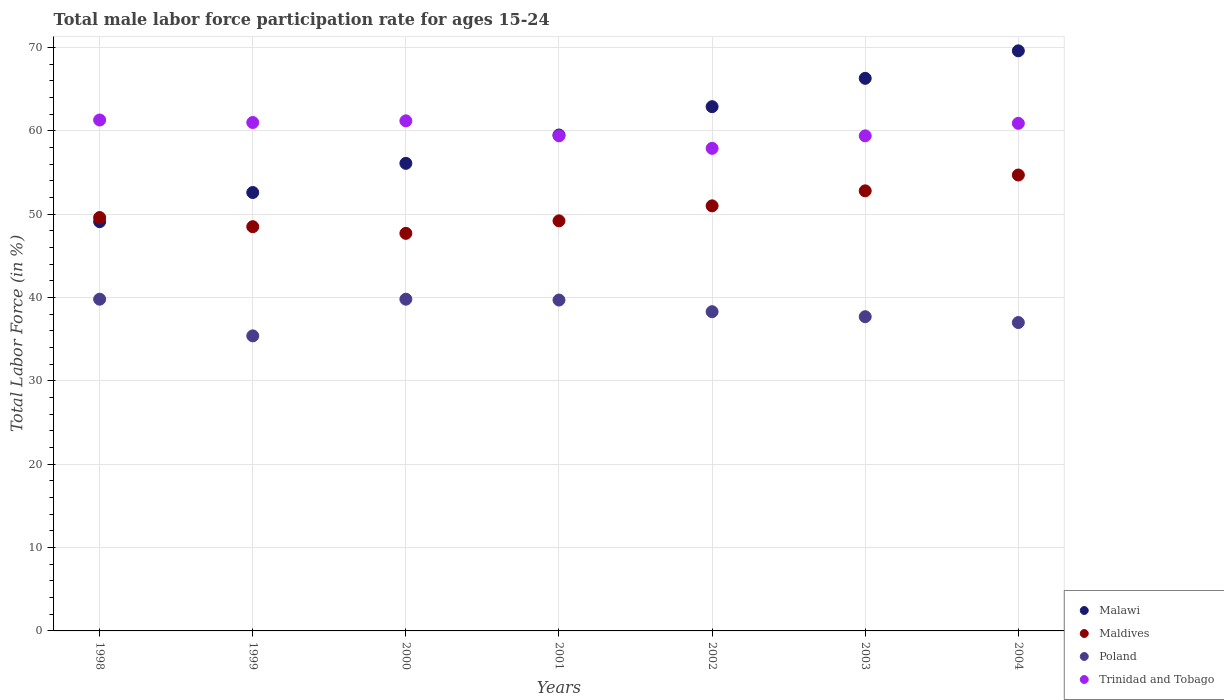What is the male labor force participation rate in Maldives in 1999?
Your answer should be compact. 48.5. Across all years, what is the maximum male labor force participation rate in Poland?
Provide a succinct answer. 39.8. Across all years, what is the minimum male labor force participation rate in Trinidad and Tobago?
Offer a very short reply. 57.9. In which year was the male labor force participation rate in Trinidad and Tobago maximum?
Offer a terse response. 1998. What is the total male labor force participation rate in Trinidad and Tobago in the graph?
Your answer should be compact. 421.1. What is the difference between the male labor force participation rate in Malawi in 2000 and that in 2001?
Offer a very short reply. -3.4. What is the difference between the male labor force participation rate in Trinidad and Tobago in 1998 and the male labor force participation rate in Malawi in 2003?
Provide a short and direct response. -5. What is the average male labor force participation rate in Poland per year?
Offer a very short reply. 38.24. In the year 2003, what is the difference between the male labor force participation rate in Poland and male labor force participation rate in Malawi?
Offer a terse response. -28.6. In how many years, is the male labor force participation rate in Malawi greater than 44 %?
Your answer should be compact. 7. What is the ratio of the male labor force participation rate in Trinidad and Tobago in 2000 to that in 2001?
Offer a terse response. 1.03. Is the difference between the male labor force participation rate in Poland in 2000 and 2004 greater than the difference between the male labor force participation rate in Malawi in 2000 and 2004?
Offer a very short reply. Yes. What is the difference between the highest and the second highest male labor force participation rate in Trinidad and Tobago?
Provide a succinct answer. 0.1. What is the difference between the highest and the lowest male labor force participation rate in Maldives?
Provide a succinct answer. 7. Is the sum of the male labor force participation rate in Trinidad and Tobago in 2001 and 2003 greater than the maximum male labor force participation rate in Maldives across all years?
Your response must be concise. Yes. Is it the case that in every year, the sum of the male labor force participation rate in Trinidad and Tobago and male labor force participation rate in Maldives  is greater than the sum of male labor force participation rate in Malawi and male labor force participation rate in Poland?
Give a very brief answer. No. Is the male labor force participation rate in Maldives strictly greater than the male labor force participation rate in Poland over the years?
Keep it short and to the point. Yes. How many years are there in the graph?
Ensure brevity in your answer.  7. Does the graph contain any zero values?
Offer a terse response. No. Does the graph contain grids?
Your answer should be very brief. Yes. Where does the legend appear in the graph?
Provide a succinct answer. Bottom right. How many legend labels are there?
Keep it short and to the point. 4. What is the title of the graph?
Give a very brief answer. Total male labor force participation rate for ages 15-24. Does "Poland" appear as one of the legend labels in the graph?
Your response must be concise. Yes. What is the Total Labor Force (in %) in Malawi in 1998?
Make the answer very short. 49.1. What is the Total Labor Force (in %) in Maldives in 1998?
Provide a short and direct response. 49.6. What is the Total Labor Force (in %) of Poland in 1998?
Provide a succinct answer. 39.8. What is the Total Labor Force (in %) of Trinidad and Tobago in 1998?
Your response must be concise. 61.3. What is the Total Labor Force (in %) of Malawi in 1999?
Ensure brevity in your answer.  52.6. What is the Total Labor Force (in %) of Maldives in 1999?
Keep it short and to the point. 48.5. What is the Total Labor Force (in %) of Poland in 1999?
Your answer should be compact. 35.4. What is the Total Labor Force (in %) in Malawi in 2000?
Provide a succinct answer. 56.1. What is the Total Labor Force (in %) of Maldives in 2000?
Make the answer very short. 47.7. What is the Total Labor Force (in %) of Poland in 2000?
Offer a terse response. 39.8. What is the Total Labor Force (in %) in Trinidad and Tobago in 2000?
Provide a short and direct response. 61.2. What is the Total Labor Force (in %) of Malawi in 2001?
Make the answer very short. 59.5. What is the Total Labor Force (in %) in Maldives in 2001?
Offer a very short reply. 49.2. What is the Total Labor Force (in %) of Poland in 2001?
Your answer should be compact. 39.7. What is the Total Labor Force (in %) of Trinidad and Tobago in 2001?
Provide a succinct answer. 59.4. What is the Total Labor Force (in %) in Malawi in 2002?
Your answer should be compact. 62.9. What is the Total Labor Force (in %) of Maldives in 2002?
Provide a succinct answer. 51. What is the Total Labor Force (in %) of Poland in 2002?
Offer a terse response. 38.3. What is the Total Labor Force (in %) of Trinidad and Tobago in 2002?
Keep it short and to the point. 57.9. What is the Total Labor Force (in %) of Malawi in 2003?
Your answer should be very brief. 66.3. What is the Total Labor Force (in %) of Maldives in 2003?
Make the answer very short. 52.8. What is the Total Labor Force (in %) of Poland in 2003?
Keep it short and to the point. 37.7. What is the Total Labor Force (in %) of Trinidad and Tobago in 2003?
Keep it short and to the point. 59.4. What is the Total Labor Force (in %) in Malawi in 2004?
Your answer should be very brief. 69.6. What is the Total Labor Force (in %) in Maldives in 2004?
Your response must be concise. 54.7. What is the Total Labor Force (in %) of Poland in 2004?
Provide a short and direct response. 37. What is the Total Labor Force (in %) of Trinidad and Tobago in 2004?
Provide a succinct answer. 60.9. Across all years, what is the maximum Total Labor Force (in %) of Malawi?
Provide a succinct answer. 69.6. Across all years, what is the maximum Total Labor Force (in %) of Maldives?
Make the answer very short. 54.7. Across all years, what is the maximum Total Labor Force (in %) of Poland?
Your response must be concise. 39.8. Across all years, what is the maximum Total Labor Force (in %) in Trinidad and Tobago?
Ensure brevity in your answer.  61.3. Across all years, what is the minimum Total Labor Force (in %) of Malawi?
Offer a terse response. 49.1. Across all years, what is the minimum Total Labor Force (in %) of Maldives?
Make the answer very short. 47.7. Across all years, what is the minimum Total Labor Force (in %) in Poland?
Provide a succinct answer. 35.4. Across all years, what is the minimum Total Labor Force (in %) in Trinidad and Tobago?
Provide a succinct answer. 57.9. What is the total Total Labor Force (in %) of Malawi in the graph?
Your answer should be compact. 416.1. What is the total Total Labor Force (in %) of Maldives in the graph?
Your answer should be very brief. 353.5. What is the total Total Labor Force (in %) of Poland in the graph?
Make the answer very short. 267.7. What is the total Total Labor Force (in %) of Trinidad and Tobago in the graph?
Give a very brief answer. 421.1. What is the difference between the Total Labor Force (in %) in Malawi in 1998 and that in 1999?
Keep it short and to the point. -3.5. What is the difference between the Total Labor Force (in %) of Poland in 1998 and that in 1999?
Offer a terse response. 4.4. What is the difference between the Total Labor Force (in %) of Poland in 1998 and that in 2000?
Provide a short and direct response. 0. What is the difference between the Total Labor Force (in %) of Trinidad and Tobago in 1998 and that in 2000?
Offer a terse response. 0.1. What is the difference between the Total Labor Force (in %) in Poland in 1998 and that in 2001?
Ensure brevity in your answer.  0.1. What is the difference between the Total Labor Force (in %) in Trinidad and Tobago in 1998 and that in 2001?
Keep it short and to the point. 1.9. What is the difference between the Total Labor Force (in %) of Malawi in 1998 and that in 2002?
Provide a short and direct response. -13.8. What is the difference between the Total Labor Force (in %) in Poland in 1998 and that in 2002?
Ensure brevity in your answer.  1.5. What is the difference between the Total Labor Force (in %) in Malawi in 1998 and that in 2003?
Your response must be concise. -17.2. What is the difference between the Total Labor Force (in %) in Malawi in 1998 and that in 2004?
Your answer should be compact. -20.5. What is the difference between the Total Labor Force (in %) of Maldives in 1998 and that in 2004?
Offer a terse response. -5.1. What is the difference between the Total Labor Force (in %) of Malawi in 1999 and that in 2000?
Your answer should be compact. -3.5. What is the difference between the Total Labor Force (in %) of Maldives in 1999 and that in 2000?
Your answer should be compact. 0.8. What is the difference between the Total Labor Force (in %) in Trinidad and Tobago in 1999 and that in 2000?
Your response must be concise. -0.2. What is the difference between the Total Labor Force (in %) of Maldives in 1999 and that in 2001?
Provide a short and direct response. -0.7. What is the difference between the Total Labor Force (in %) in Poland in 1999 and that in 2001?
Provide a short and direct response. -4.3. What is the difference between the Total Labor Force (in %) in Trinidad and Tobago in 1999 and that in 2001?
Offer a terse response. 1.6. What is the difference between the Total Labor Force (in %) in Malawi in 1999 and that in 2002?
Offer a terse response. -10.3. What is the difference between the Total Labor Force (in %) in Trinidad and Tobago in 1999 and that in 2002?
Your answer should be compact. 3.1. What is the difference between the Total Labor Force (in %) of Malawi in 1999 and that in 2003?
Your answer should be compact. -13.7. What is the difference between the Total Labor Force (in %) of Poland in 1999 and that in 2003?
Make the answer very short. -2.3. What is the difference between the Total Labor Force (in %) in Trinidad and Tobago in 1999 and that in 2003?
Provide a short and direct response. 1.6. What is the difference between the Total Labor Force (in %) in Maldives in 1999 and that in 2004?
Your answer should be compact. -6.2. What is the difference between the Total Labor Force (in %) of Poland in 1999 and that in 2004?
Make the answer very short. -1.6. What is the difference between the Total Labor Force (in %) of Poland in 2000 and that in 2001?
Make the answer very short. 0.1. What is the difference between the Total Labor Force (in %) in Trinidad and Tobago in 2000 and that in 2001?
Provide a succinct answer. 1.8. What is the difference between the Total Labor Force (in %) of Malawi in 2000 and that in 2002?
Your answer should be compact. -6.8. What is the difference between the Total Labor Force (in %) of Malawi in 2000 and that in 2003?
Give a very brief answer. -10.2. What is the difference between the Total Labor Force (in %) in Maldives in 2000 and that in 2004?
Keep it short and to the point. -7. What is the difference between the Total Labor Force (in %) in Poland in 2000 and that in 2004?
Offer a terse response. 2.8. What is the difference between the Total Labor Force (in %) of Malawi in 2001 and that in 2002?
Ensure brevity in your answer.  -3.4. What is the difference between the Total Labor Force (in %) of Poland in 2001 and that in 2002?
Keep it short and to the point. 1.4. What is the difference between the Total Labor Force (in %) in Malawi in 2001 and that in 2003?
Your answer should be very brief. -6.8. What is the difference between the Total Labor Force (in %) of Maldives in 2001 and that in 2003?
Provide a short and direct response. -3.6. What is the difference between the Total Labor Force (in %) of Poland in 2001 and that in 2003?
Keep it short and to the point. 2. What is the difference between the Total Labor Force (in %) in Malawi in 2002 and that in 2003?
Your answer should be very brief. -3.4. What is the difference between the Total Labor Force (in %) in Maldives in 2002 and that in 2003?
Keep it short and to the point. -1.8. What is the difference between the Total Labor Force (in %) of Maldives in 2002 and that in 2004?
Your answer should be very brief. -3.7. What is the difference between the Total Labor Force (in %) of Poland in 2003 and that in 2004?
Keep it short and to the point. 0.7. What is the difference between the Total Labor Force (in %) in Malawi in 1998 and the Total Labor Force (in %) in Poland in 1999?
Make the answer very short. 13.7. What is the difference between the Total Labor Force (in %) in Maldives in 1998 and the Total Labor Force (in %) in Poland in 1999?
Your response must be concise. 14.2. What is the difference between the Total Labor Force (in %) of Poland in 1998 and the Total Labor Force (in %) of Trinidad and Tobago in 1999?
Make the answer very short. -21.2. What is the difference between the Total Labor Force (in %) of Malawi in 1998 and the Total Labor Force (in %) of Maldives in 2000?
Ensure brevity in your answer.  1.4. What is the difference between the Total Labor Force (in %) in Maldives in 1998 and the Total Labor Force (in %) in Trinidad and Tobago in 2000?
Keep it short and to the point. -11.6. What is the difference between the Total Labor Force (in %) of Poland in 1998 and the Total Labor Force (in %) of Trinidad and Tobago in 2000?
Provide a short and direct response. -21.4. What is the difference between the Total Labor Force (in %) of Malawi in 1998 and the Total Labor Force (in %) of Poland in 2001?
Keep it short and to the point. 9.4. What is the difference between the Total Labor Force (in %) of Malawi in 1998 and the Total Labor Force (in %) of Trinidad and Tobago in 2001?
Provide a short and direct response. -10.3. What is the difference between the Total Labor Force (in %) of Maldives in 1998 and the Total Labor Force (in %) of Poland in 2001?
Your answer should be very brief. 9.9. What is the difference between the Total Labor Force (in %) of Poland in 1998 and the Total Labor Force (in %) of Trinidad and Tobago in 2001?
Provide a succinct answer. -19.6. What is the difference between the Total Labor Force (in %) in Malawi in 1998 and the Total Labor Force (in %) in Maldives in 2002?
Make the answer very short. -1.9. What is the difference between the Total Labor Force (in %) of Malawi in 1998 and the Total Labor Force (in %) of Trinidad and Tobago in 2002?
Give a very brief answer. -8.8. What is the difference between the Total Labor Force (in %) of Poland in 1998 and the Total Labor Force (in %) of Trinidad and Tobago in 2002?
Provide a short and direct response. -18.1. What is the difference between the Total Labor Force (in %) of Malawi in 1998 and the Total Labor Force (in %) of Maldives in 2003?
Provide a short and direct response. -3.7. What is the difference between the Total Labor Force (in %) of Malawi in 1998 and the Total Labor Force (in %) of Poland in 2003?
Your response must be concise. 11.4. What is the difference between the Total Labor Force (in %) of Maldives in 1998 and the Total Labor Force (in %) of Trinidad and Tobago in 2003?
Offer a terse response. -9.8. What is the difference between the Total Labor Force (in %) in Poland in 1998 and the Total Labor Force (in %) in Trinidad and Tobago in 2003?
Make the answer very short. -19.6. What is the difference between the Total Labor Force (in %) in Malawi in 1998 and the Total Labor Force (in %) in Maldives in 2004?
Keep it short and to the point. -5.6. What is the difference between the Total Labor Force (in %) of Maldives in 1998 and the Total Labor Force (in %) of Trinidad and Tobago in 2004?
Ensure brevity in your answer.  -11.3. What is the difference between the Total Labor Force (in %) of Poland in 1998 and the Total Labor Force (in %) of Trinidad and Tobago in 2004?
Provide a succinct answer. -21.1. What is the difference between the Total Labor Force (in %) of Malawi in 1999 and the Total Labor Force (in %) of Poland in 2000?
Your response must be concise. 12.8. What is the difference between the Total Labor Force (in %) of Maldives in 1999 and the Total Labor Force (in %) of Trinidad and Tobago in 2000?
Provide a short and direct response. -12.7. What is the difference between the Total Labor Force (in %) in Poland in 1999 and the Total Labor Force (in %) in Trinidad and Tobago in 2000?
Offer a terse response. -25.8. What is the difference between the Total Labor Force (in %) of Malawi in 1999 and the Total Labor Force (in %) of Maldives in 2001?
Make the answer very short. 3.4. What is the difference between the Total Labor Force (in %) in Malawi in 1999 and the Total Labor Force (in %) in Trinidad and Tobago in 2001?
Make the answer very short. -6.8. What is the difference between the Total Labor Force (in %) in Maldives in 1999 and the Total Labor Force (in %) in Trinidad and Tobago in 2001?
Ensure brevity in your answer.  -10.9. What is the difference between the Total Labor Force (in %) of Poland in 1999 and the Total Labor Force (in %) of Trinidad and Tobago in 2001?
Offer a very short reply. -24. What is the difference between the Total Labor Force (in %) in Malawi in 1999 and the Total Labor Force (in %) in Trinidad and Tobago in 2002?
Ensure brevity in your answer.  -5.3. What is the difference between the Total Labor Force (in %) in Poland in 1999 and the Total Labor Force (in %) in Trinidad and Tobago in 2002?
Your answer should be very brief. -22.5. What is the difference between the Total Labor Force (in %) in Malawi in 1999 and the Total Labor Force (in %) in Poland in 2003?
Offer a very short reply. 14.9. What is the difference between the Total Labor Force (in %) in Malawi in 1999 and the Total Labor Force (in %) in Trinidad and Tobago in 2003?
Make the answer very short. -6.8. What is the difference between the Total Labor Force (in %) in Maldives in 1999 and the Total Labor Force (in %) in Poland in 2003?
Provide a succinct answer. 10.8. What is the difference between the Total Labor Force (in %) in Maldives in 1999 and the Total Labor Force (in %) in Trinidad and Tobago in 2003?
Your response must be concise. -10.9. What is the difference between the Total Labor Force (in %) in Malawi in 1999 and the Total Labor Force (in %) in Maldives in 2004?
Provide a short and direct response. -2.1. What is the difference between the Total Labor Force (in %) in Malawi in 1999 and the Total Labor Force (in %) in Poland in 2004?
Your answer should be compact. 15.6. What is the difference between the Total Labor Force (in %) of Malawi in 1999 and the Total Labor Force (in %) of Trinidad and Tobago in 2004?
Give a very brief answer. -8.3. What is the difference between the Total Labor Force (in %) of Maldives in 1999 and the Total Labor Force (in %) of Trinidad and Tobago in 2004?
Offer a very short reply. -12.4. What is the difference between the Total Labor Force (in %) of Poland in 1999 and the Total Labor Force (in %) of Trinidad and Tobago in 2004?
Make the answer very short. -25.5. What is the difference between the Total Labor Force (in %) of Malawi in 2000 and the Total Labor Force (in %) of Poland in 2001?
Ensure brevity in your answer.  16.4. What is the difference between the Total Labor Force (in %) of Malawi in 2000 and the Total Labor Force (in %) of Trinidad and Tobago in 2001?
Provide a short and direct response. -3.3. What is the difference between the Total Labor Force (in %) in Maldives in 2000 and the Total Labor Force (in %) in Poland in 2001?
Offer a very short reply. 8. What is the difference between the Total Labor Force (in %) in Poland in 2000 and the Total Labor Force (in %) in Trinidad and Tobago in 2001?
Offer a very short reply. -19.6. What is the difference between the Total Labor Force (in %) of Malawi in 2000 and the Total Labor Force (in %) of Maldives in 2002?
Give a very brief answer. 5.1. What is the difference between the Total Labor Force (in %) of Malawi in 2000 and the Total Labor Force (in %) of Poland in 2002?
Your answer should be compact. 17.8. What is the difference between the Total Labor Force (in %) of Maldives in 2000 and the Total Labor Force (in %) of Poland in 2002?
Offer a very short reply. 9.4. What is the difference between the Total Labor Force (in %) in Poland in 2000 and the Total Labor Force (in %) in Trinidad and Tobago in 2002?
Your answer should be compact. -18.1. What is the difference between the Total Labor Force (in %) of Malawi in 2000 and the Total Labor Force (in %) of Maldives in 2003?
Provide a succinct answer. 3.3. What is the difference between the Total Labor Force (in %) in Poland in 2000 and the Total Labor Force (in %) in Trinidad and Tobago in 2003?
Your answer should be very brief. -19.6. What is the difference between the Total Labor Force (in %) in Maldives in 2000 and the Total Labor Force (in %) in Poland in 2004?
Offer a terse response. 10.7. What is the difference between the Total Labor Force (in %) in Poland in 2000 and the Total Labor Force (in %) in Trinidad and Tobago in 2004?
Give a very brief answer. -21.1. What is the difference between the Total Labor Force (in %) in Malawi in 2001 and the Total Labor Force (in %) in Poland in 2002?
Your answer should be very brief. 21.2. What is the difference between the Total Labor Force (in %) of Malawi in 2001 and the Total Labor Force (in %) of Trinidad and Tobago in 2002?
Your answer should be very brief. 1.6. What is the difference between the Total Labor Force (in %) in Poland in 2001 and the Total Labor Force (in %) in Trinidad and Tobago in 2002?
Provide a succinct answer. -18.2. What is the difference between the Total Labor Force (in %) in Malawi in 2001 and the Total Labor Force (in %) in Maldives in 2003?
Provide a short and direct response. 6.7. What is the difference between the Total Labor Force (in %) of Malawi in 2001 and the Total Labor Force (in %) of Poland in 2003?
Keep it short and to the point. 21.8. What is the difference between the Total Labor Force (in %) in Poland in 2001 and the Total Labor Force (in %) in Trinidad and Tobago in 2003?
Offer a very short reply. -19.7. What is the difference between the Total Labor Force (in %) in Malawi in 2001 and the Total Labor Force (in %) in Poland in 2004?
Your answer should be compact. 22.5. What is the difference between the Total Labor Force (in %) in Maldives in 2001 and the Total Labor Force (in %) in Trinidad and Tobago in 2004?
Give a very brief answer. -11.7. What is the difference between the Total Labor Force (in %) in Poland in 2001 and the Total Labor Force (in %) in Trinidad and Tobago in 2004?
Your response must be concise. -21.2. What is the difference between the Total Labor Force (in %) in Malawi in 2002 and the Total Labor Force (in %) in Maldives in 2003?
Offer a terse response. 10.1. What is the difference between the Total Labor Force (in %) in Malawi in 2002 and the Total Labor Force (in %) in Poland in 2003?
Offer a terse response. 25.2. What is the difference between the Total Labor Force (in %) of Malawi in 2002 and the Total Labor Force (in %) of Trinidad and Tobago in 2003?
Give a very brief answer. 3.5. What is the difference between the Total Labor Force (in %) in Maldives in 2002 and the Total Labor Force (in %) in Poland in 2003?
Make the answer very short. 13.3. What is the difference between the Total Labor Force (in %) in Poland in 2002 and the Total Labor Force (in %) in Trinidad and Tobago in 2003?
Give a very brief answer. -21.1. What is the difference between the Total Labor Force (in %) of Malawi in 2002 and the Total Labor Force (in %) of Maldives in 2004?
Provide a short and direct response. 8.2. What is the difference between the Total Labor Force (in %) of Malawi in 2002 and the Total Labor Force (in %) of Poland in 2004?
Offer a terse response. 25.9. What is the difference between the Total Labor Force (in %) of Malawi in 2002 and the Total Labor Force (in %) of Trinidad and Tobago in 2004?
Your response must be concise. 2. What is the difference between the Total Labor Force (in %) of Maldives in 2002 and the Total Labor Force (in %) of Poland in 2004?
Make the answer very short. 14. What is the difference between the Total Labor Force (in %) of Poland in 2002 and the Total Labor Force (in %) of Trinidad and Tobago in 2004?
Your answer should be very brief. -22.6. What is the difference between the Total Labor Force (in %) in Malawi in 2003 and the Total Labor Force (in %) in Maldives in 2004?
Make the answer very short. 11.6. What is the difference between the Total Labor Force (in %) in Malawi in 2003 and the Total Labor Force (in %) in Poland in 2004?
Make the answer very short. 29.3. What is the difference between the Total Labor Force (in %) in Malawi in 2003 and the Total Labor Force (in %) in Trinidad and Tobago in 2004?
Your answer should be compact. 5.4. What is the difference between the Total Labor Force (in %) of Poland in 2003 and the Total Labor Force (in %) of Trinidad and Tobago in 2004?
Make the answer very short. -23.2. What is the average Total Labor Force (in %) in Malawi per year?
Your response must be concise. 59.44. What is the average Total Labor Force (in %) in Maldives per year?
Make the answer very short. 50.5. What is the average Total Labor Force (in %) of Poland per year?
Provide a short and direct response. 38.24. What is the average Total Labor Force (in %) of Trinidad and Tobago per year?
Your response must be concise. 60.16. In the year 1998, what is the difference between the Total Labor Force (in %) of Malawi and Total Labor Force (in %) of Poland?
Your answer should be very brief. 9.3. In the year 1998, what is the difference between the Total Labor Force (in %) of Maldives and Total Labor Force (in %) of Trinidad and Tobago?
Your answer should be compact. -11.7. In the year 1998, what is the difference between the Total Labor Force (in %) of Poland and Total Labor Force (in %) of Trinidad and Tobago?
Ensure brevity in your answer.  -21.5. In the year 1999, what is the difference between the Total Labor Force (in %) in Malawi and Total Labor Force (in %) in Poland?
Provide a succinct answer. 17.2. In the year 1999, what is the difference between the Total Labor Force (in %) of Maldives and Total Labor Force (in %) of Poland?
Your response must be concise. 13.1. In the year 1999, what is the difference between the Total Labor Force (in %) in Poland and Total Labor Force (in %) in Trinidad and Tobago?
Your response must be concise. -25.6. In the year 2000, what is the difference between the Total Labor Force (in %) in Malawi and Total Labor Force (in %) in Trinidad and Tobago?
Your answer should be compact. -5.1. In the year 2000, what is the difference between the Total Labor Force (in %) in Maldives and Total Labor Force (in %) in Poland?
Give a very brief answer. 7.9. In the year 2000, what is the difference between the Total Labor Force (in %) in Poland and Total Labor Force (in %) in Trinidad and Tobago?
Offer a terse response. -21.4. In the year 2001, what is the difference between the Total Labor Force (in %) of Malawi and Total Labor Force (in %) of Poland?
Provide a succinct answer. 19.8. In the year 2001, what is the difference between the Total Labor Force (in %) of Malawi and Total Labor Force (in %) of Trinidad and Tobago?
Your answer should be very brief. 0.1. In the year 2001, what is the difference between the Total Labor Force (in %) of Maldives and Total Labor Force (in %) of Poland?
Your answer should be very brief. 9.5. In the year 2001, what is the difference between the Total Labor Force (in %) in Poland and Total Labor Force (in %) in Trinidad and Tobago?
Provide a succinct answer. -19.7. In the year 2002, what is the difference between the Total Labor Force (in %) of Malawi and Total Labor Force (in %) of Maldives?
Your response must be concise. 11.9. In the year 2002, what is the difference between the Total Labor Force (in %) in Malawi and Total Labor Force (in %) in Poland?
Provide a short and direct response. 24.6. In the year 2002, what is the difference between the Total Labor Force (in %) in Malawi and Total Labor Force (in %) in Trinidad and Tobago?
Your response must be concise. 5. In the year 2002, what is the difference between the Total Labor Force (in %) in Poland and Total Labor Force (in %) in Trinidad and Tobago?
Provide a succinct answer. -19.6. In the year 2003, what is the difference between the Total Labor Force (in %) in Malawi and Total Labor Force (in %) in Maldives?
Offer a terse response. 13.5. In the year 2003, what is the difference between the Total Labor Force (in %) of Malawi and Total Labor Force (in %) of Poland?
Ensure brevity in your answer.  28.6. In the year 2003, what is the difference between the Total Labor Force (in %) in Malawi and Total Labor Force (in %) in Trinidad and Tobago?
Give a very brief answer. 6.9. In the year 2003, what is the difference between the Total Labor Force (in %) in Poland and Total Labor Force (in %) in Trinidad and Tobago?
Provide a succinct answer. -21.7. In the year 2004, what is the difference between the Total Labor Force (in %) in Malawi and Total Labor Force (in %) in Maldives?
Provide a succinct answer. 14.9. In the year 2004, what is the difference between the Total Labor Force (in %) in Malawi and Total Labor Force (in %) in Poland?
Keep it short and to the point. 32.6. In the year 2004, what is the difference between the Total Labor Force (in %) in Malawi and Total Labor Force (in %) in Trinidad and Tobago?
Your response must be concise. 8.7. In the year 2004, what is the difference between the Total Labor Force (in %) of Maldives and Total Labor Force (in %) of Poland?
Your answer should be compact. 17.7. In the year 2004, what is the difference between the Total Labor Force (in %) in Maldives and Total Labor Force (in %) in Trinidad and Tobago?
Your response must be concise. -6.2. In the year 2004, what is the difference between the Total Labor Force (in %) in Poland and Total Labor Force (in %) in Trinidad and Tobago?
Offer a terse response. -23.9. What is the ratio of the Total Labor Force (in %) in Malawi in 1998 to that in 1999?
Give a very brief answer. 0.93. What is the ratio of the Total Labor Force (in %) in Maldives in 1998 to that in 1999?
Your answer should be compact. 1.02. What is the ratio of the Total Labor Force (in %) of Poland in 1998 to that in 1999?
Make the answer very short. 1.12. What is the ratio of the Total Labor Force (in %) of Trinidad and Tobago in 1998 to that in 1999?
Your answer should be very brief. 1. What is the ratio of the Total Labor Force (in %) in Malawi in 1998 to that in 2000?
Your answer should be very brief. 0.88. What is the ratio of the Total Labor Force (in %) in Maldives in 1998 to that in 2000?
Your answer should be compact. 1.04. What is the ratio of the Total Labor Force (in %) of Poland in 1998 to that in 2000?
Your answer should be compact. 1. What is the ratio of the Total Labor Force (in %) in Malawi in 1998 to that in 2001?
Provide a succinct answer. 0.83. What is the ratio of the Total Labor Force (in %) of Maldives in 1998 to that in 2001?
Give a very brief answer. 1.01. What is the ratio of the Total Labor Force (in %) of Poland in 1998 to that in 2001?
Offer a terse response. 1. What is the ratio of the Total Labor Force (in %) in Trinidad and Tobago in 1998 to that in 2001?
Ensure brevity in your answer.  1.03. What is the ratio of the Total Labor Force (in %) of Malawi in 1998 to that in 2002?
Your response must be concise. 0.78. What is the ratio of the Total Labor Force (in %) of Maldives in 1998 to that in 2002?
Provide a succinct answer. 0.97. What is the ratio of the Total Labor Force (in %) of Poland in 1998 to that in 2002?
Offer a terse response. 1.04. What is the ratio of the Total Labor Force (in %) in Trinidad and Tobago in 1998 to that in 2002?
Your response must be concise. 1.06. What is the ratio of the Total Labor Force (in %) in Malawi in 1998 to that in 2003?
Offer a very short reply. 0.74. What is the ratio of the Total Labor Force (in %) of Maldives in 1998 to that in 2003?
Offer a very short reply. 0.94. What is the ratio of the Total Labor Force (in %) in Poland in 1998 to that in 2003?
Offer a terse response. 1.06. What is the ratio of the Total Labor Force (in %) of Trinidad and Tobago in 1998 to that in 2003?
Keep it short and to the point. 1.03. What is the ratio of the Total Labor Force (in %) of Malawi in 1998 to that in 2004?
Provide a succinct answer. 0.71. What is the ratio of the Total Labor Force (in %) in Maldives in 1998 to that in 2004?
Offer a very short reply. 0.91. What is the ratio of the Total Labor Force (in %) of Poland in 1998 to that in 2004?
Offer a terse response. 1.08. What is the ratio of the Total Labor Force (in %) in Trinidad and Tobago in 1998 to that in 2004?
Your response must be concise. 1.01. What is the ratio of the Total Labor Force (in %) in Malawi in 1999 to that in 2000?
Your answer should be very brief. 0.94. What is the ratio of the Total Labor Force (in %) in Maldives in 1999 to that in 2000?
Ensure brevity in your answer.  1.02. What is the ratio of the Total Labor Force (in %) of Poland in 1999 to that in 2000?
Provide a succinct answer. 0.89. What is the ratio of the Total Labor Force (in %) in Trinidad and Tobago in 1999 to that in 2000?
Keep it short and to the point. 1. What is the ratio of the Total Labor Force (in %) of Malawi in 1999 to that in 2001?
Make the answer very short. 0.88. What is the ratio of the Total Labor Force (in %) of Maldives in 1999 to that in 2001?
Give a very brief answer. 0.99. What is the ratio of the Total Labor Force (in %) of Poland in 1999 to that in 2001?
Give a very brief answer. 0.89. What is the ratio of the Total Labor Force (in %) in Trinidad and Tobago in 1999 to that in 2001?
Your response must be concise. 1.03. What is the ratio of the Total Labor Force (in %) in Malawi in 1999 to that in 2002?
Provide a succinct answer. 0.84. What is the ratio of the Total Labor Force (in %) in Maldives in 1999 to that in 2002?
Provide a short and direct response. 0.95. What is the ratio of the Total Labor Force (in %) of Poland in 1999 to that in 2002?
Make the answer very short. 0.92. What is the ratio of the Total Labor Force (in %) of Trinidad and Tobago in 1999 to that in 2002?
Offer a very short reply. 1.05. What is the ratio of the Total Labor Force (in %) of Malawi in 1999 to that in 2003?
Offer a terse response. 0.79. What is the ratio of the Total Labor Force (in %) in Maldives in 1999 to that in 2003?
Make the answer very short. 0.92. What is the ratio of the Total Labor Force (in %) of Poland in 1999 to that in 2003?
Your response must be concise. 0.94. What is the ratio of the Total Labor Force (in %) in Trinidad and Tobago in 1999 to that in 2003?
Your answer should be very brief. 1.03. What is the ratio of the Total Labor Force (in %) in Malawi in 1999 to that in 2004?
Your response must be concise. 0.76. What is the ratio of the Total Labor Force (in %) in Maldives in 1999 to that in 2004?
Make the answer very short. 0.89. What is the ratio of the Total Labor Force (in %) in Poland in 1999 to that in 2004?
Offer a terse response. 0.96. What is the ratio of the Total Labor Force (in %) of Trinidad and Tobago in 1999 to that in 2004?
Make the answer very short. 1. What is the ratio of the Total Labor Force (in %) in Malawi in 2000 to that in 2001?
Make the answer very short. 0.94. What is the ratio of the Total Labor Force (in %) of Maldives in 2000 to that in 2001?
Your answer should be very brief. 0.97. What is the ratio of the Total Labor Force (in %) of Trinidad and Tobago in 2000 to that in 2001?
Offer a very short reply. 1.03. What is the ratio of the Total Labor Force (in %) in Malawi in 2000 to that in 2002?
Offer a terse response. 0.89. What is the ratio of the Total Labor Force (in %) of Maldives in 2000 to that in 2002?
Your answer should be compact. 0.94. What is the ratio of the Total Labor Force (in %) of Poland in 2000 to that in 2002?
Provide a short and direct response. 1.04. What is the ratio of the Total Labor Force (in %) in Trinidad and Tobago in 2000 to that in 2002?
Keep it short and to the point. 1.06. What is the ratio of the Total Labor Force (in %) in Malawi in 2000 to that in 2003?
Give a very brief answer. 0.85. What is the ratio of the Total Labor Force (in %) in Maldives in 2000 to that in 2003?
Your answer should be compact. 0.9. What is the ratio of the Total Labor Force (in %) in Poland in 2000 to that in 2003?
Offer a terse response. 1.06. What is the ratio of the Total Labor Force (in %) of Trinidad and Tobago in 2000 to that in 2003?
Ensure brevity in your answer.  1.03. What is the ratio of the Total Labor Force (in %) in Malawi in 2000 to that in 2004?
Ensure brevity in your answer.  0.81. What is the ratio of the Total Labor Force (in %) of Maldives in 2000 to that in 2004?
Ensure brevity in your answer.  0.87. What is the ratio of the Total Labor Force (in %) of Poland in 2000 to that in 2004?
Your answer should be very brief. 1.08. What is the ratio of the Total Labor Force (in %) of Trinidad and Tobago in 2000 to that in 2004?
Offer a very short reply. 1. What is the ratio of the Total Labor Force (in %) of Malawi in 2001 to that in 2002?
Offer a very short reply. 0.95. What is the ratio of the Total Labor Force (in %) in Maldives in 2001 to that in 2002?
Ensure brevity in your answer.  0.96. What is the ratio of the Total Labor Force (in %) in Poland in 2001 to that in 2002?
Your answer should be compact. 1.04. What is the ratio of the Total Labor Force (in %) of Trinidad and Tobago in 2001 to that in 2002?
Provide a succinct answer. 1.03. What is the ratio of the Total Labor Force (in %) of Malawi in 2001 to that in 2003?
Keep it short and to the point. 0.9. What is the ratio of the Total Labor Force (in %) in Maldives in 2001 to that in 2003?
Ensure brevity in your answer.  0.93. What is the ratio of the Total Labor Force (in %) in Poland in 2001 to that in 2003?
Offer a terse response. 1.05. What is the ratio of the Total Labor Force (in %) in Malawi in 2001 to that in 2004?
Your response must be concise. 0.85. What is the ratio of the Total Labor Force (in %) in Maldives in 2001 to that in 2004?
Your answer should be compact. 0.9. What is the ratio of the Total Labor Force (in %) of Poland in 2001 to that in 2004?
Make the answer very short. 1.07. What is the ratio of the Total Labor Force (in %) of Trinidad and Tobago in 2001 to that in 2004?
Ensure brevity in your answer.  0.98. What is the ratio of the Total Labor Force (in %) in Malawi in 2002 to that in 2003?
Give a very brief answer. 0.95. What is the ratio of the Total Labor Force (in %) of Maldives in 2002 to that in 2003?
Your answer should be very brief. 0.97. What is the ratio of the Total Labor Force (in %) in Poland in 2002 to that in 2003?
Make the answer very short. 1.02. What is the ratio of the Total Labor Force (in %) of Trinidad and Tobago in 2002 to that in 2003?
Offer a very short reply. 0.97. What is the ratio of the Total Labor Force (in %) of Malawi in 2002 to that in 2004?
Provide a short and direct response. 0.9. What is the ratio of the Total Labor Force (in %) in Maldives in 2002 to that in 2004?
Provide a short and direct response. 0.93. What is the ratio of the Total Labor Force (in %) of Poland in 2002 to that in 2004?
Your response must be concise. 1.04. What is the ratio of the Total Labor Force (in %) of Trinidad and Tobago in 2002 to that in 2004?
Offer a terse response. 0.95. What is the ratio of the Total Labor Force (in %) in Malawi in 2003 to that in 2004?
Your answer should be compact. 0.95. What is the ratio of the Total Labor Force (in %) of Maldives in 2003 to that in 2004?
Offer a terse response. 0.97. What is the ratio of the Total Labor Force (in %) of Poland in 2003 to that in 2004?
Your response must be concise. 1.02. What is the ratio of the Total Labor Force (in %) in Trinidad and Tobago in 2003 to that in 2004?
Offer a terse response. 0.98. What is the difference between the highest and the second highest Total Labor Force (in %) in Malawi?
Your response must be concise. 3.3. What is the difference between the highest and the second highest Total Labor Force (in %) in Poland?
Ensure brevity in your answer.  0. What is the difference between the highest and the second highest Total Labor Force (in %) of Trinidad and Tobago?
Provide a short and direct response. 0.1. What is the difference between the highest and the lowest Total Labor Force (in %) in Poland?
Offer a very short reply. 4.4. 